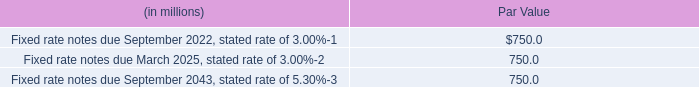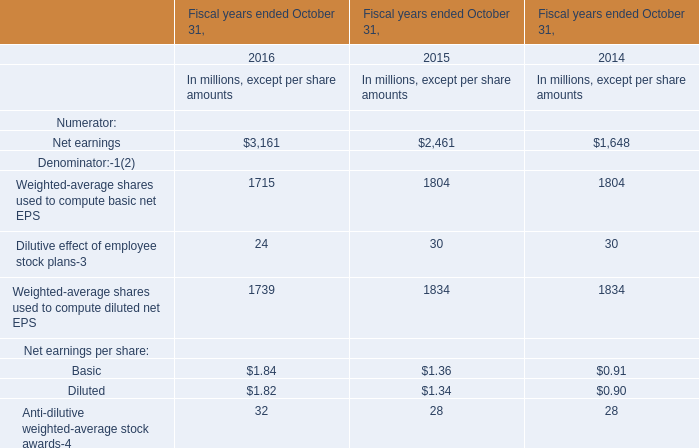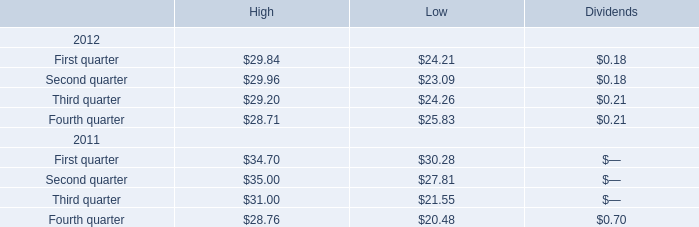what was the decrease in the interest payable between august 2012 and in december 2014? 
Computations: (3.11 - 3.32)
Answer: -0.21. 